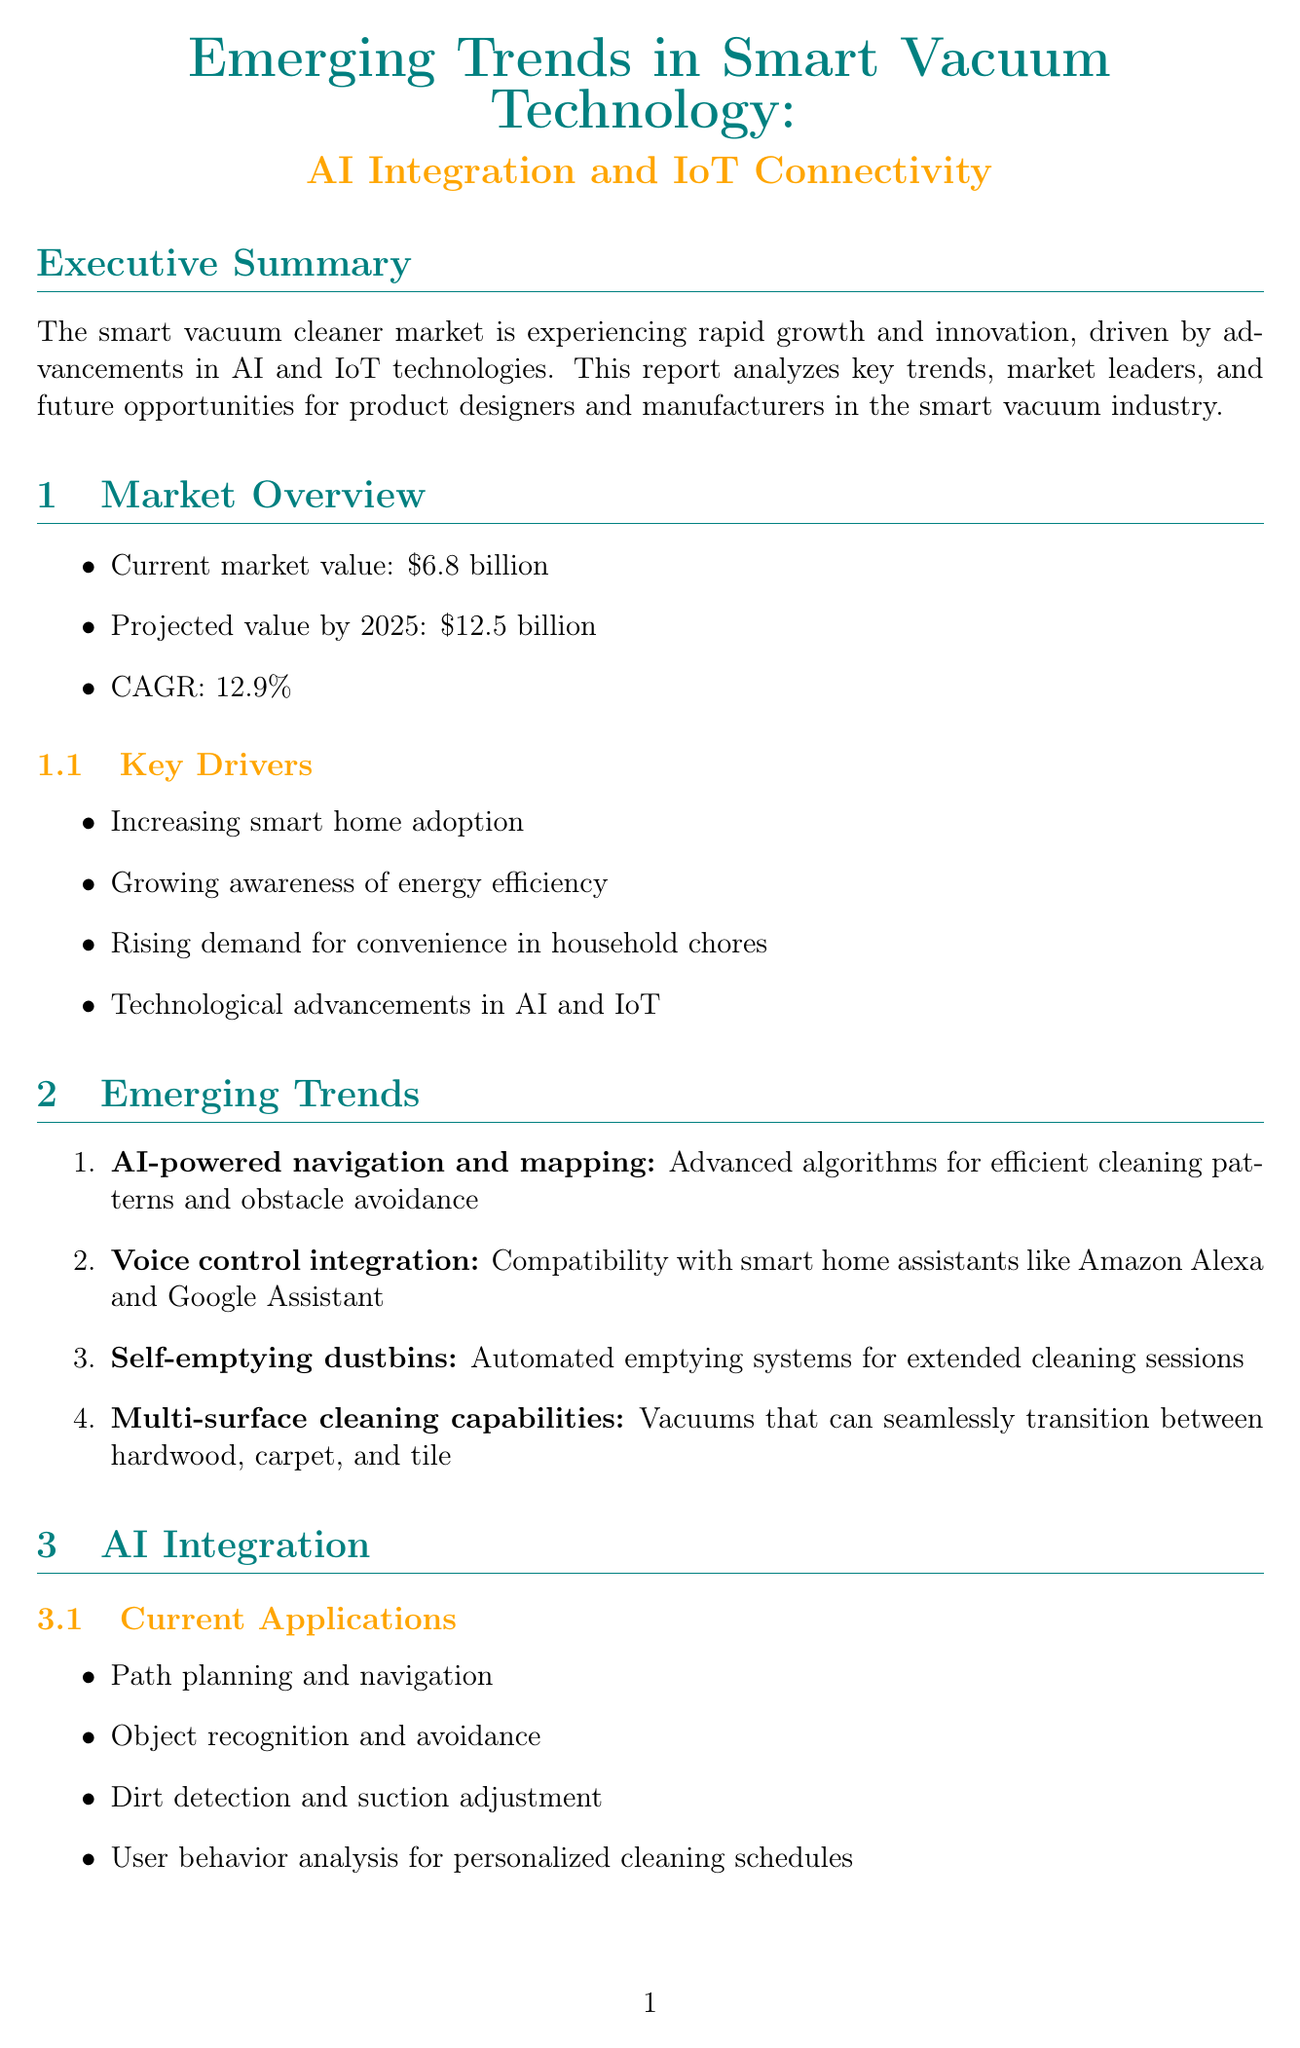What is the current market value of smart vacuum cleaners? The current market value of smart vacuum cleaners is noted in the document as $6.8 billion.
Answer: $6.8 billion What is the projected market value by 2025? The projected market value by 2025 is stated in the document as $12.5 billion.
Answer: $12.5 billion What is the CAGR of the smart vacuum cleaner market? The Compound Annual Growth Rate (CAGR) mentioned in the document is 12.9%.
Answer: 12.9% Which company has the flagship product Roomba j7+? The document identifies iRobot as the company with the flagship product Roomba j7+.
Answer: iRobot What are two key drivers for the smart vacuum cleaner market? The document lists several key drivers, two of which are increasing smart home adoption and growing awareness of energy efficiency.
Answer: Increasing smart home adoption, growing awareness of energy efficiency What is a significant challenge of IoT connectivity mentioned in the report? The document mentions data privacy and security concerns as a challenge of IoT connectivity.
Answer: Data privacy and security concerns What is a suggested design implication for product developers? One suggested design implication in the document is to develop advanced object detection and avoidance systems.
Answer: Develop advanced object detection and avoidance systems What AI application relates to personalized cleaning schedules? The document states that user behavior analysis for personalized cleaning schedules is a current AI application.
Answer: User behavior analysis for personalized cleaning schedules Which emerging player is mentioned in the competitive landscape? The document includes Narwal Robotics as one of the emerging players in the competitive landscape.
Answer: Narwal Robotics 